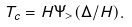<formula> <loc_0><loc_0><loc_500><loc_500>T _ { c } = H \Psi _ { > } ( \Delta / H ) .</formula> 